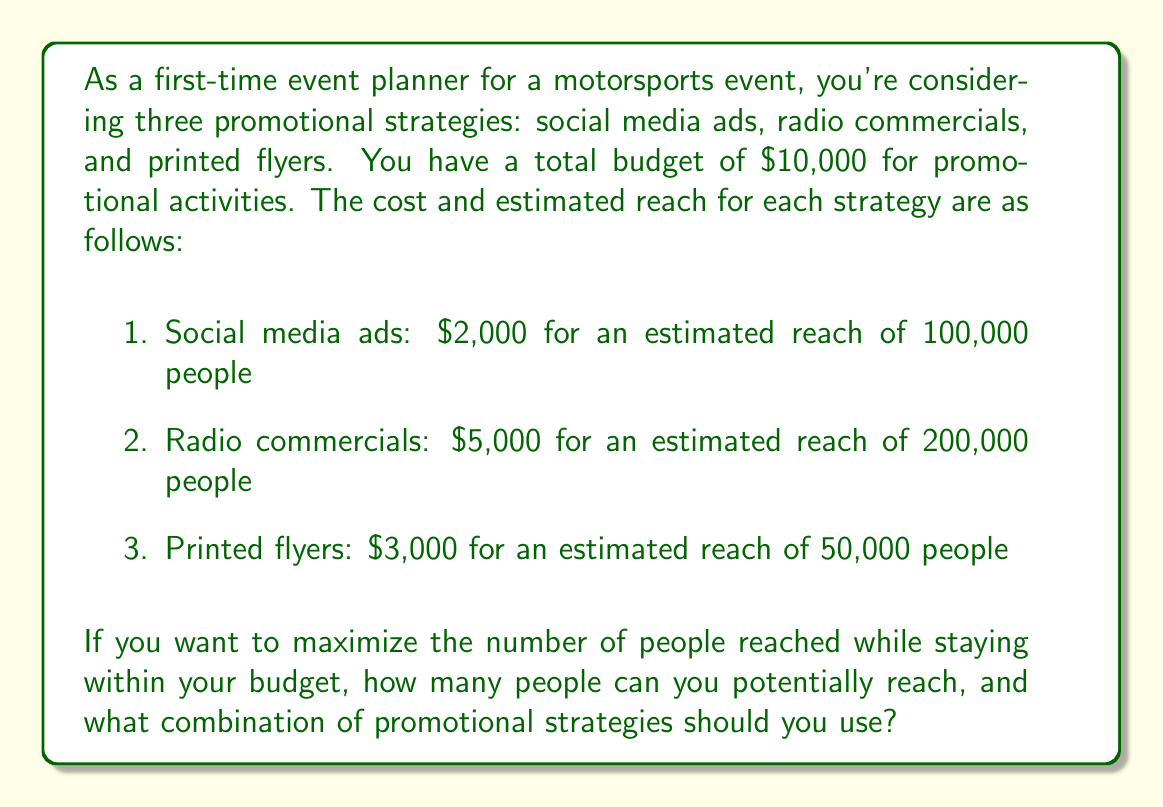Help me with this question. To solve this problem, we need to use a simple optimization approach. Let's break it down step-by-step:

1. Define variables:
   Let $x$ = number of social media ad campaigns
   Let $y$ = number of radio commercial campaigns
   Let $z$ = number of printed flyer campaigns

2. Set up the objective function:
   We want to maximize the total reach, which is:
   $$ 100,000x + 200,000y + 50,000z $$

3. Set up the constraint:
   The total cost must not exceed $10,000:
   $$ 2,000x + 5,000y + 3,000z \leq 10,000 $$

4. Consider the integer nature of the variables:
   We can't run partial campaigns, so $x$, $y$, and $z$ must be non-negative integers.

5. Analyze possible combinations:
   a) Using only social media ads: $10,000 \div 2,000 = 5$ campaigns
      Reach: $5 \times 100,000 = 500,000$ people
   
   b) Using only radio commercials: $10,000 \div 5,000 = 2$ campaigns
      Reach: $2 \times 200,000 = 400,000$ people
   
   c) Using only printed flyers: $10,000 \div 3,000 = 3$ campaigns (with $1,000 left over)
      Reach: $3 \times 50,000 = 150,000$ people
   
   d) Optimal combination:
      2 social media campaigns ($4,000) + 1 radio campaign ($5,000) + 1 flyer campaign ($3,000)
      Total cost: $12,000 (exceeds budget)
   
   e) Best feasible combination:
      3 social media campaigns ($6,000) + 1 radio campaign ($5,000)
      Total cost: $11,000 (exceeds budget)
   
   f) Optimal feasible combination:
      4 social media campaigns ($8,000) + 1 flyer campaign ($3,000)
      Total cost: $11,000
      Reach: $(4 \times 100,000) + (1 \times 50,000) = 450,000$ people

6. The optimal solution that stays within budget is to use 4 social media ad campaigns and 1 printed flyer campaign, reaching a total of 450,000 people.
Answer: The maximum number of people that can be reached while staying within the $10,000 budget is 450,000, using a combination of 4 social media ad campaigns and 1 printed flyer campaign. 